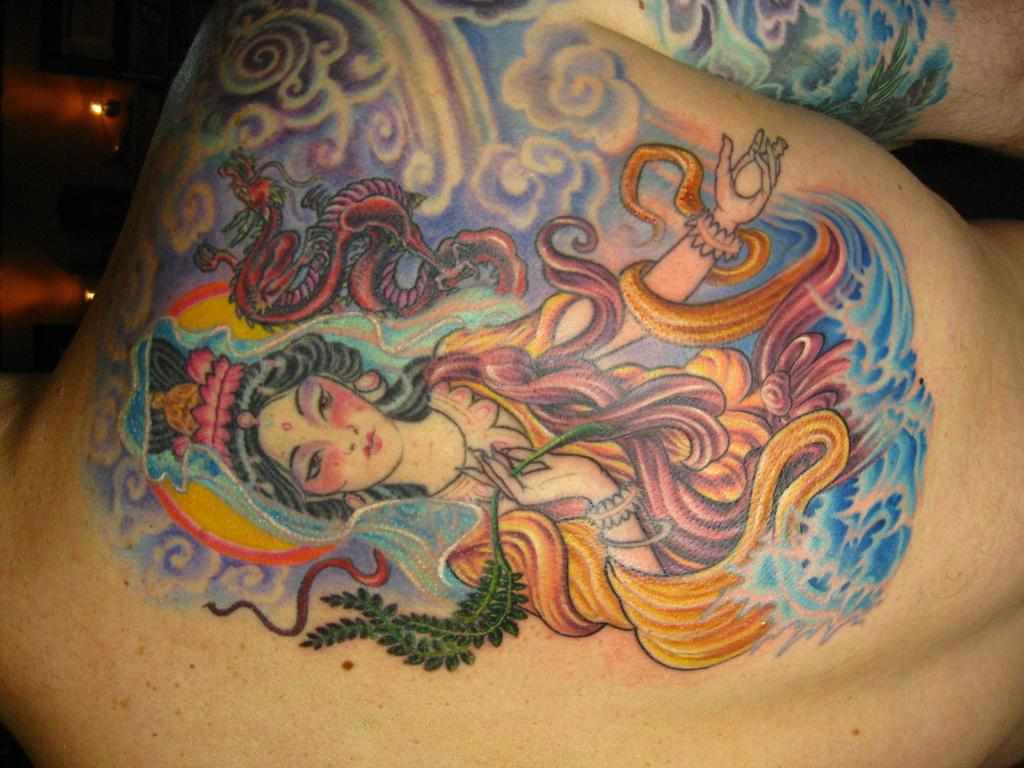What is visible on the back of the person in the image? There is a tattoo on the back of the person in the image. What type of fog can be seen surrounding the donkey in the image? There is no donkey or fog present in the image; it features a tattoo on the back of a person. 